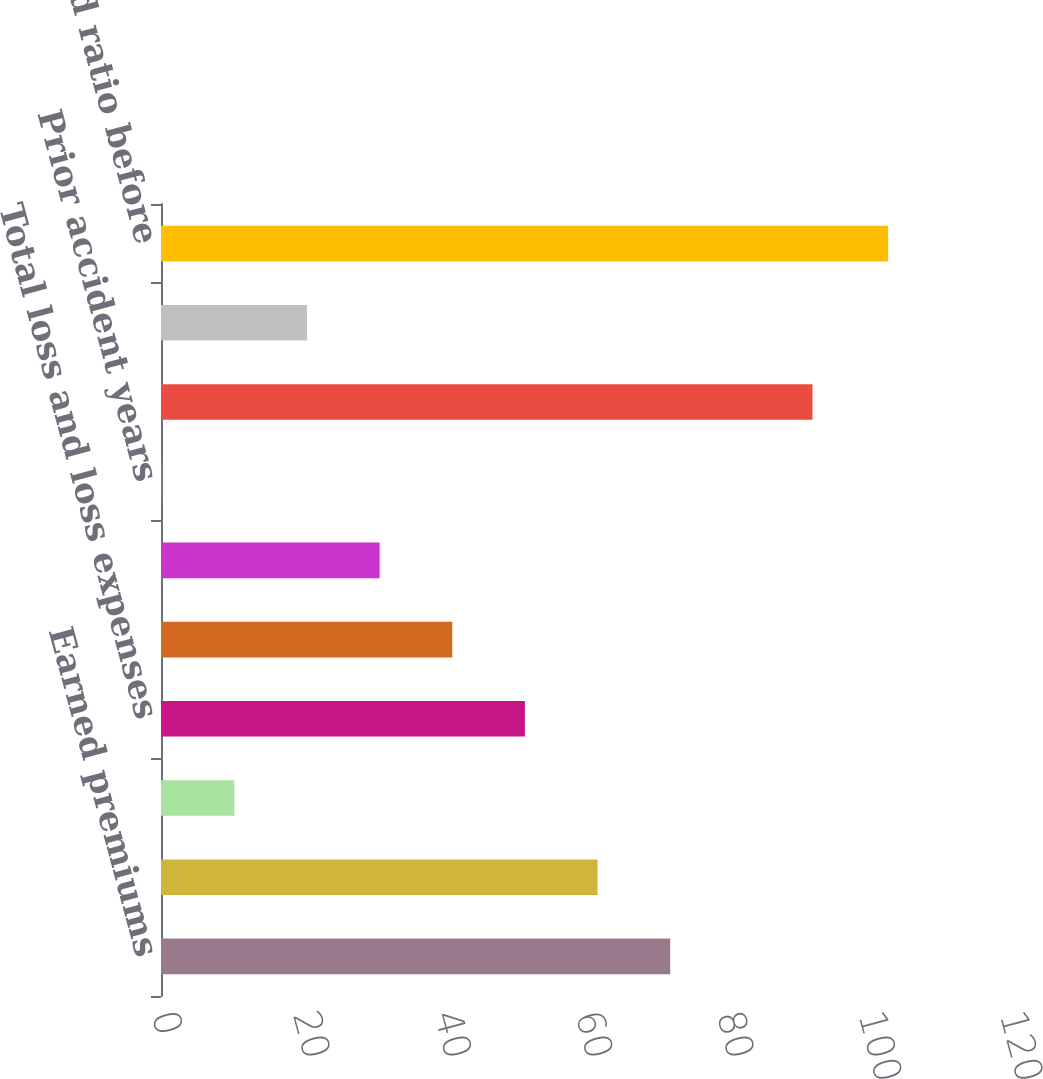Convert chart. <chart><loc_0><loc_0><loc_500><loc_500><bar_chart><fcel>Earned premiums<fcel>Current accident year before<fcel>Current accident year<fcel>Total loss and loss expenses<fcel>Underwriting expenses<fcel>Prior accident years before<fcel>Prior accident years<fcel>Combined ratio<fcel>Contribution from catastrophe<fcel>Combined ratio before<nl><fcel>72.06<fcel>61.78<fcel>10.38<fcel>51.5<fcel>41.22<fcel>30.94<fcel>0.1<fcel>92.2<fcel>20.66<fcel>102.9<nl></chart> 